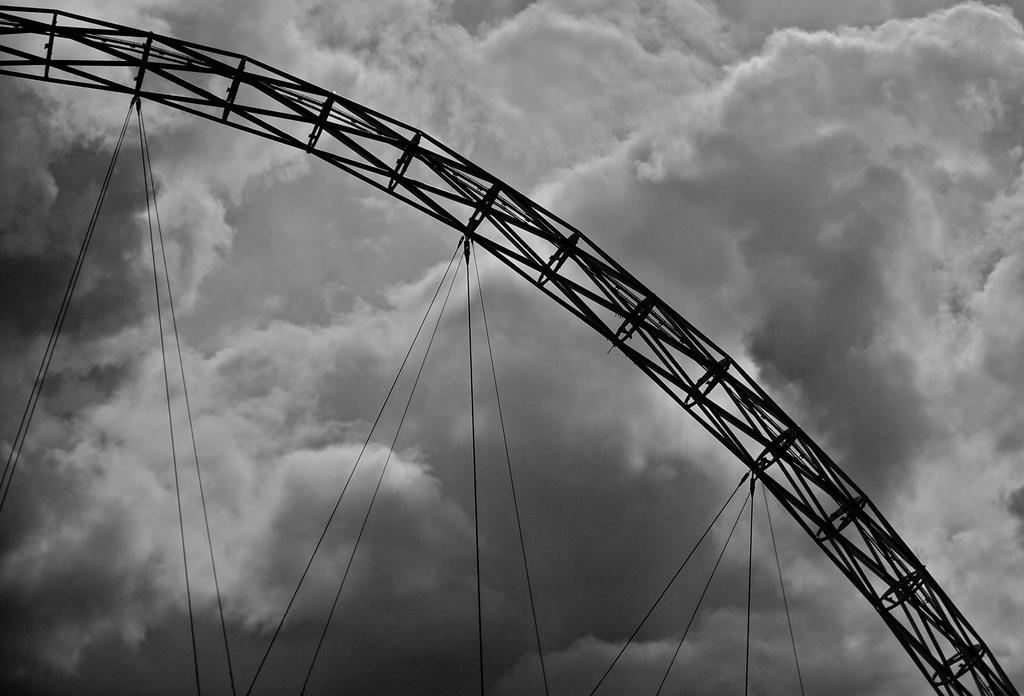What is the color scheme of the image? The image is black and white. What type of attraction can be seen in the image? There is a fun ride in the image. What can be seen in the background of the image? There are clouds and the sky visible in the background of the image. What theory does the dad explain to the mother in the image? There is no dad or mother present in the image, and therefore no such conversation can be observed. 